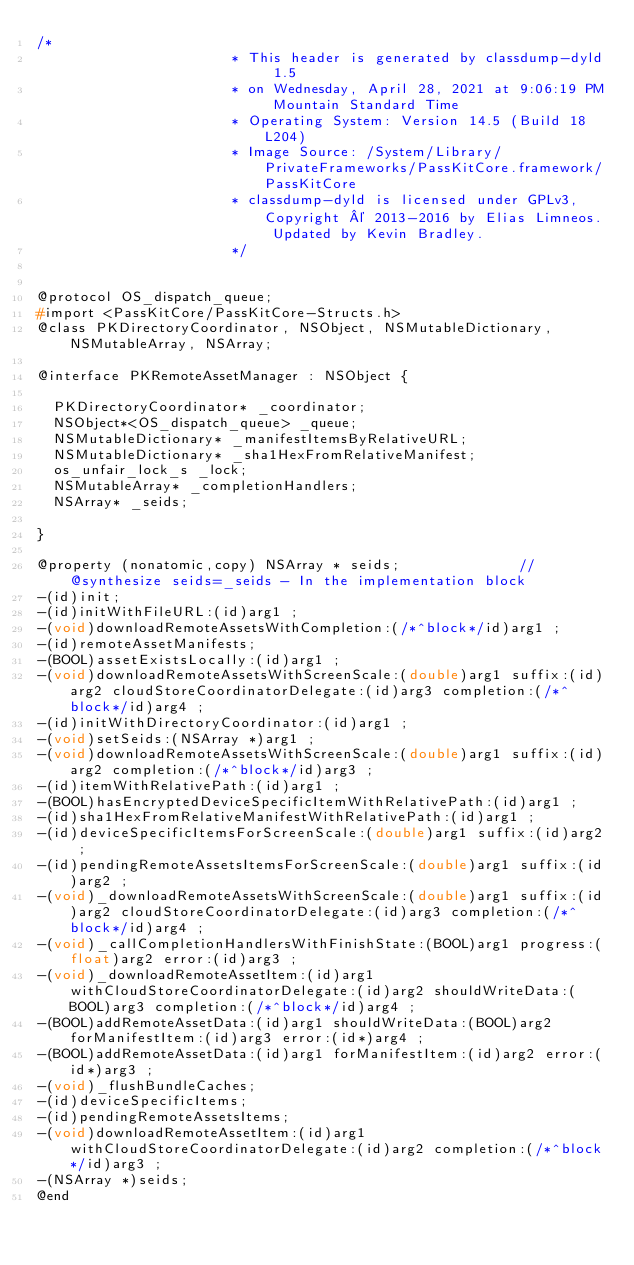Convert code to text. <code><loc_0><loc_0><loc_500><loc_500><_C_>/*
                       * This header is generated by classdump-dyld 1.5
                       * on Wednesday, April 28, 2021 at 9:06:19 PM Mountain Standard Time
                       * Operating System: Version 14.5 (Build 18L204)
                       * Image Source: /System/Library/PrivateFrameworks/PassKitCore.framework/PassKitCore
                       * classdump-dyld is licensed under GPLv3, Copyright © 2013-2016 by Elias Limneos. Updated by Kevin Bradley.
                       */


@protocol OS_dispatch_queue;
#import <PassKitCore/PassKitCore-Structs.h>
@class PKDirectoryCoordinator, NSObject, NSMutableDictionary, NSMutableArray, NSArray;

@interface PKRemoteAssetManager : NSObject {

	PKDirectoryCoordinator* _coordinator;
	NSObject*<OS_dispatch_queue> _queue;
	NSMutableDictionary* _manifestItemsByRelativeURL;
	NSMutableDictionary* _sha1HexFromRelativeManifest;
	os_unfair_lock_s _lock;
	NSMutableArray* _completionHandlers;
	NSArray* _seids;

}

@property (nonatomic,copy) NSArray * seids;              //@synthesize seids=_seids - In the implementation block
-(id)init;
-(id)initWithFileURL:(id)arg1 ;
-(void)downloadRemoteAssetsWithCompletion:(/*^block*/id)arg1 ;
-(id)remoteAssetManifests;
-(BOOL)assetExistsLocally:(id)arg1 ;
-(void)downloadRemoteAssetsWithScreenScale:(double)arg1 suffix:(id)arg2 cloudStoreCoordinatorDelegate:(id)arg3 completion:(/*^block*/id)arg4 ;
-(id)initWithDirectoryCoordinator:(id)arg1 ;
-(void)setSeids:(NSArray *)arg1 ;
-(void)downloadRemoteAssetsWithScreenScale:(double)arg1 suffix:(id)arg2 completion:(/*^block*/id)arg3 ;
-(id)itemWithRelativePath:(id)arg1 ;
-(BOOL)hasEncryptedDeviceSpecificItemWithRelativePath:(id)arg1 ;
-(id)sha1HexFromRelativeManifestWithRelativePath:(id)arg1 ;
-(id)deviceSpecificItemsForScreenScale:(double)arg1 suffix:(id)arg2 ;
-(id)pendingRemoteAssetsItemsForScreenScale:(double)arg1 suffix:(id)arg2 ;
-(void)_downloadRemoteAssetsWithScreenScale:(double)arg1 suffix:(id)arg2 cloudStoreCoordinatorDelegate:(id)arg3 completion:(/*^block*/id)arg4 ;
-(void)_callCompletionHandlersWithFinishState:(BOOL)arg1 progress:(float)arg2 error:(id)arg3 ;
-(void)_downloadRemoteAssetItem:(id)arg1 withCloudStoreCoordinatorDelegate:(id)arg2 shouldWriteData:(BOOL)arg3 completion:(/*^block*/id)arg4 ;
-(BOOL)addRemoteAssetData:(id)arg1 shouldWriteData:(BOOL)arg2 forManifestItem:(id)arg3 error:(id*)arg4 ;
-(BOOL)addRemoteAssetData:(id)arg1 forManifestItem:(id)arg2 error:(id*)arg3 ;
-(void)_flushBundleCaches;
-(id)deviceSpecificItems;
-(id)pendingRemoteAssetsItems;
-(void)downloadRemoteAssetItem:(id)arg1 withCloudStoreCoordinatorDelegate:(id)arg2 completion:(/*^block*/id)arg3 ;
-(NSArray *)seids;
@end

</code> 